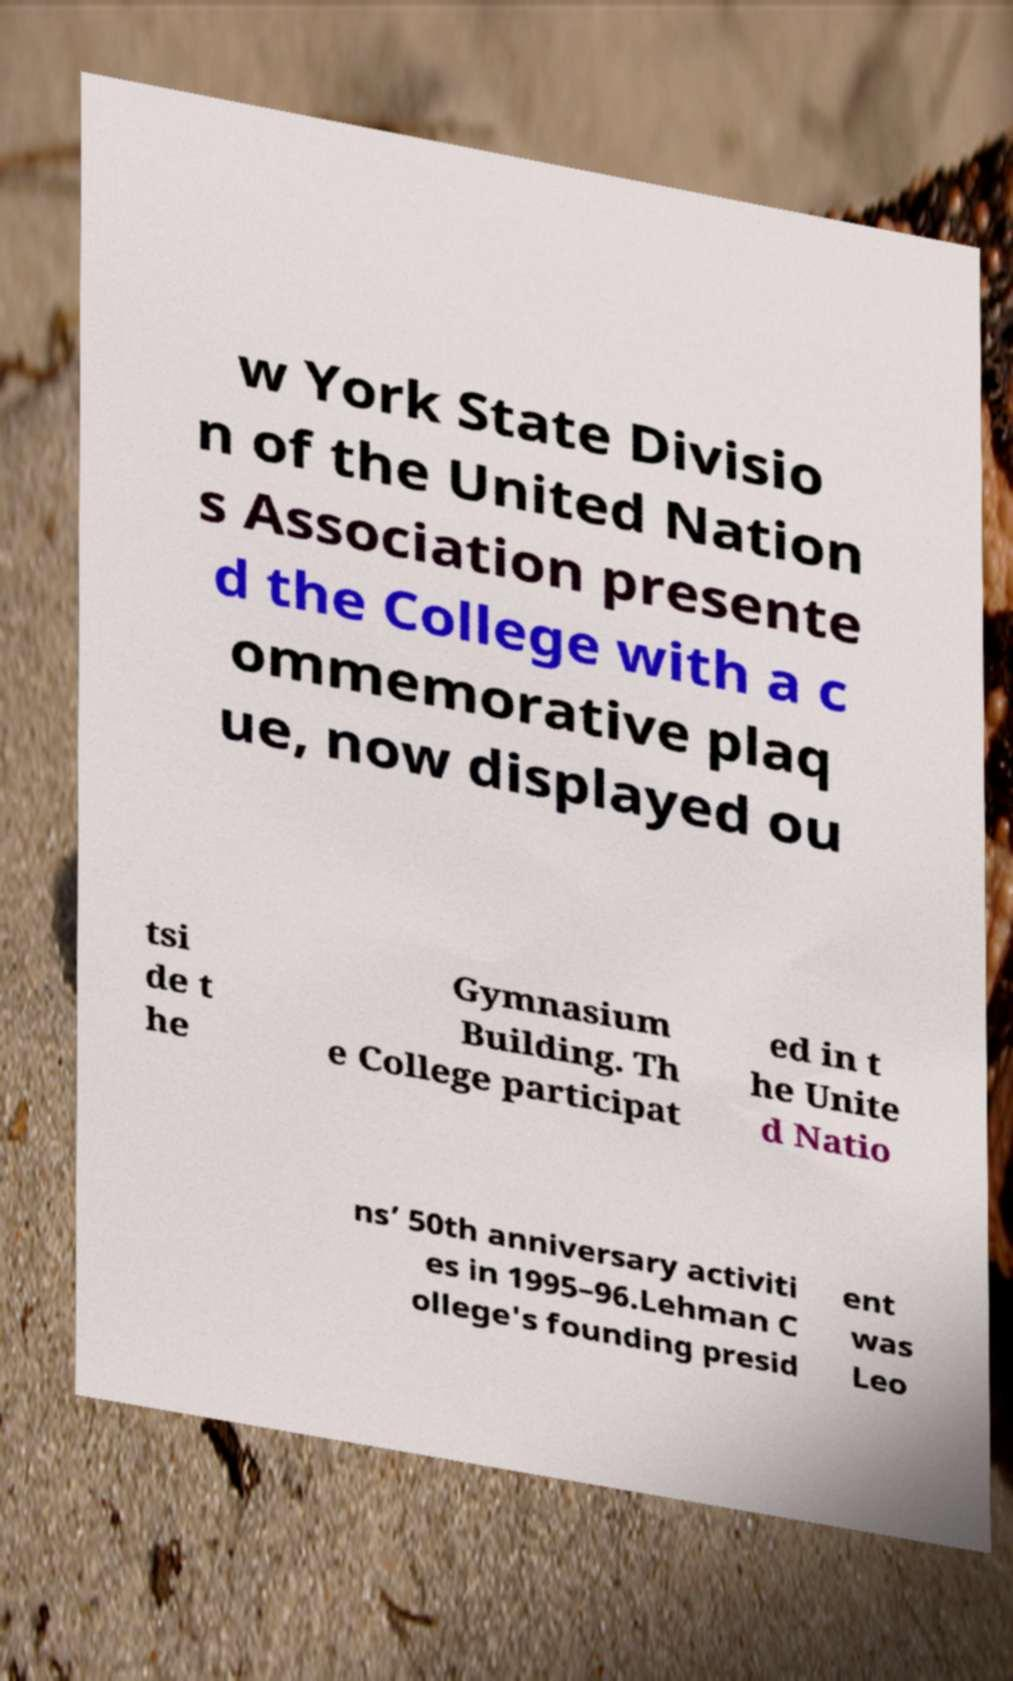Please read and relay the text visible in this image. What does it say? w York State Divisio n of the United Nation s Association presente d the College with a c ommemorative plaq ue, now displayed ou tsi de t he Gymnasium Building. Th e College participat ed in t he Unite d Natio ns’ 50th anniversary activiti es in 1995–96.Lehman C ollege's founding presid ent was Leo 